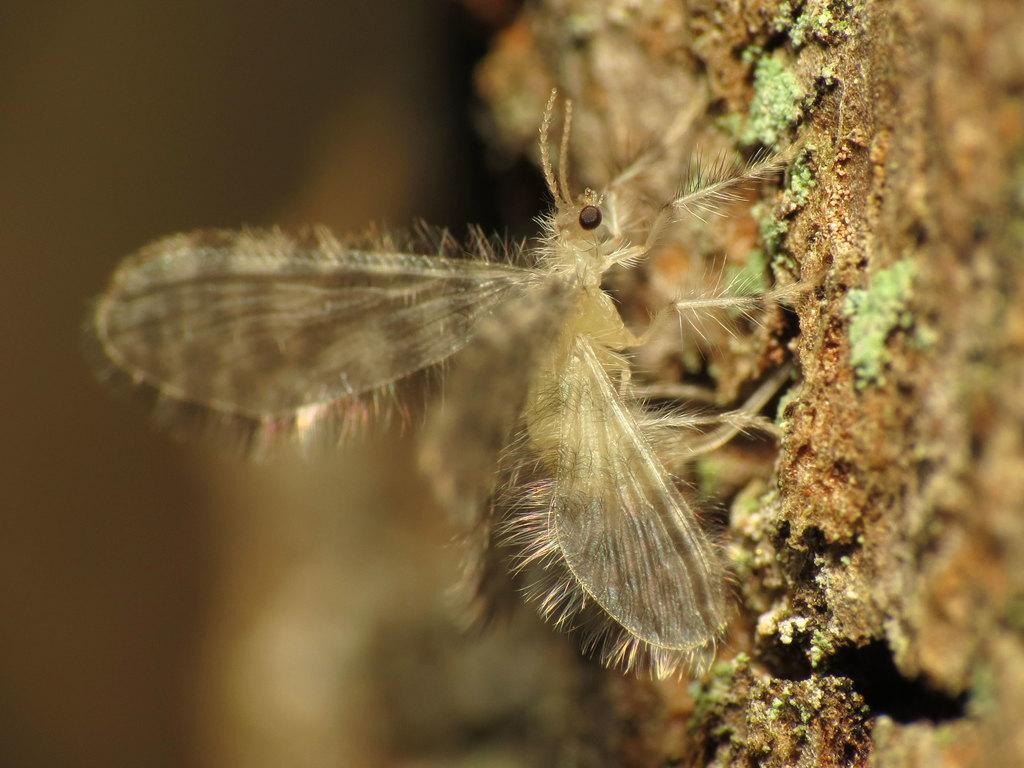What type of creature is present in the image? There is an insect in the image. What feature does the insect have? The insect has wings. Where is the insect located in the image? The insect is in mud. What other small objects can be seen in the image? There are tiny leaves in the image. What type of wound can be seen on the insect in the image? There is no wound visible on the insect in the image. 